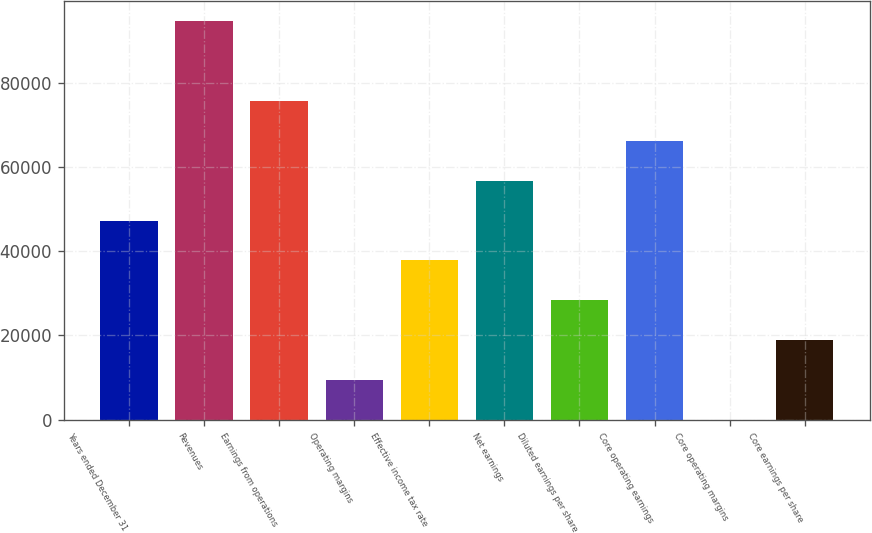<chart> <loc_0><loc_0><loc_500><loc_500><bar_chart><fcel>Years ended December 31<fcel>Revenues<fcel>Earnings from operations<fcel>Operating margins<fcel>Effective income tax rate<fcel>Net earnings<fcel>Diluted earnings per share<fcel>Core operating earnings<fcel>Core operating margins<fcel>Core earnings per share<nl><fcel>47288.4<fcel>94571<fcel>75658<fcel>9462.32<fcel>37831.9<fcel>56744.9<fcel>28375.4<fcel>66201.4<fcel>5.8<fcel>18918.8<nl></chart> 